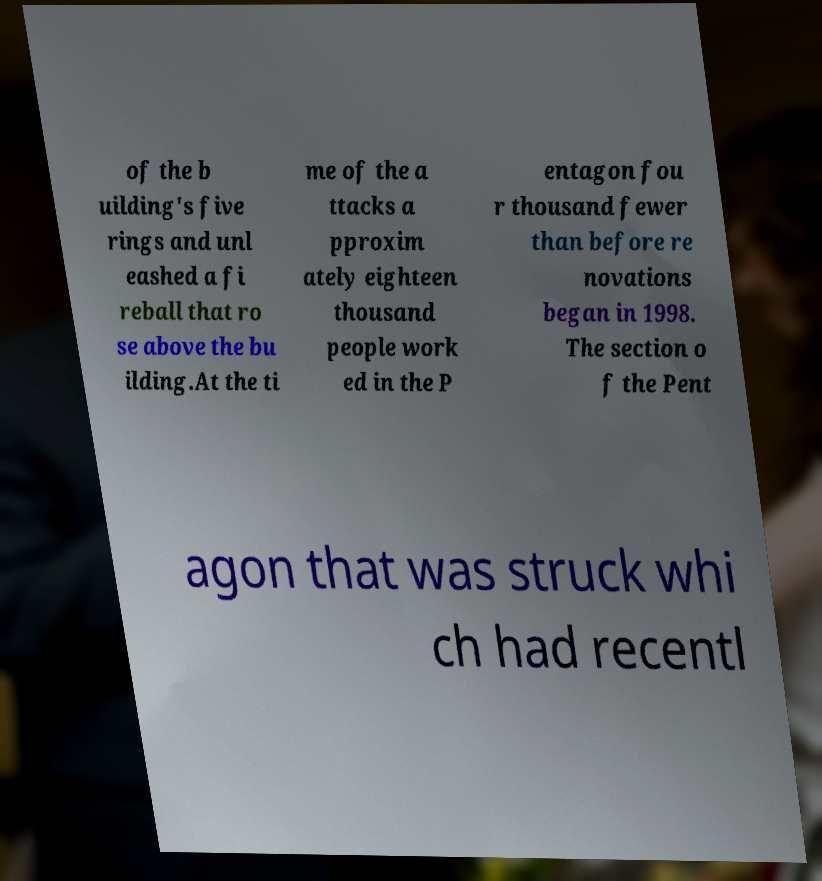Could you assist in decoding the text presented in this image and type it out clearly? of the b uilding's five rings and unl eashed a fi reball that ro se above the bu ilding.At the ti me of the a ttacks a pproxim ately eighteen thousand people work ed in the P entagon fou r thousand fewer than before re novations began in 1998. The section o f the Pent agon that was struck whi ch had recentl 